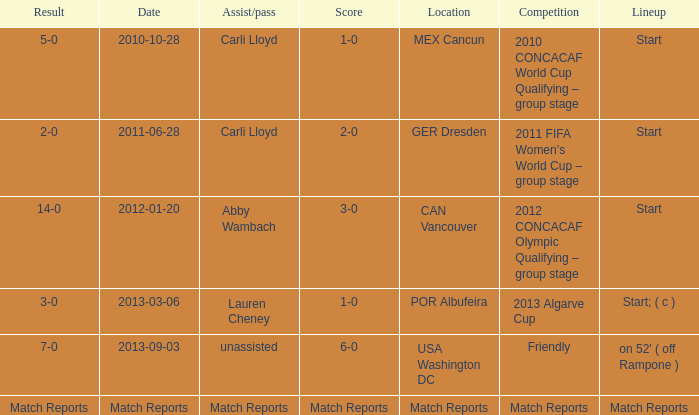Name the Result of the Lineup of start, an Assist/pass of carli lloyd, and an Competition of 2011 fifa women’s world cup – group stage? 2-0. 